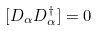Convert formula to latex. <formula><loc_0><loc_0><loc_500><loc_500>[ D _ { \alpha } D _ { \alpha } ^ { \dagger } ] = 0</formula> 